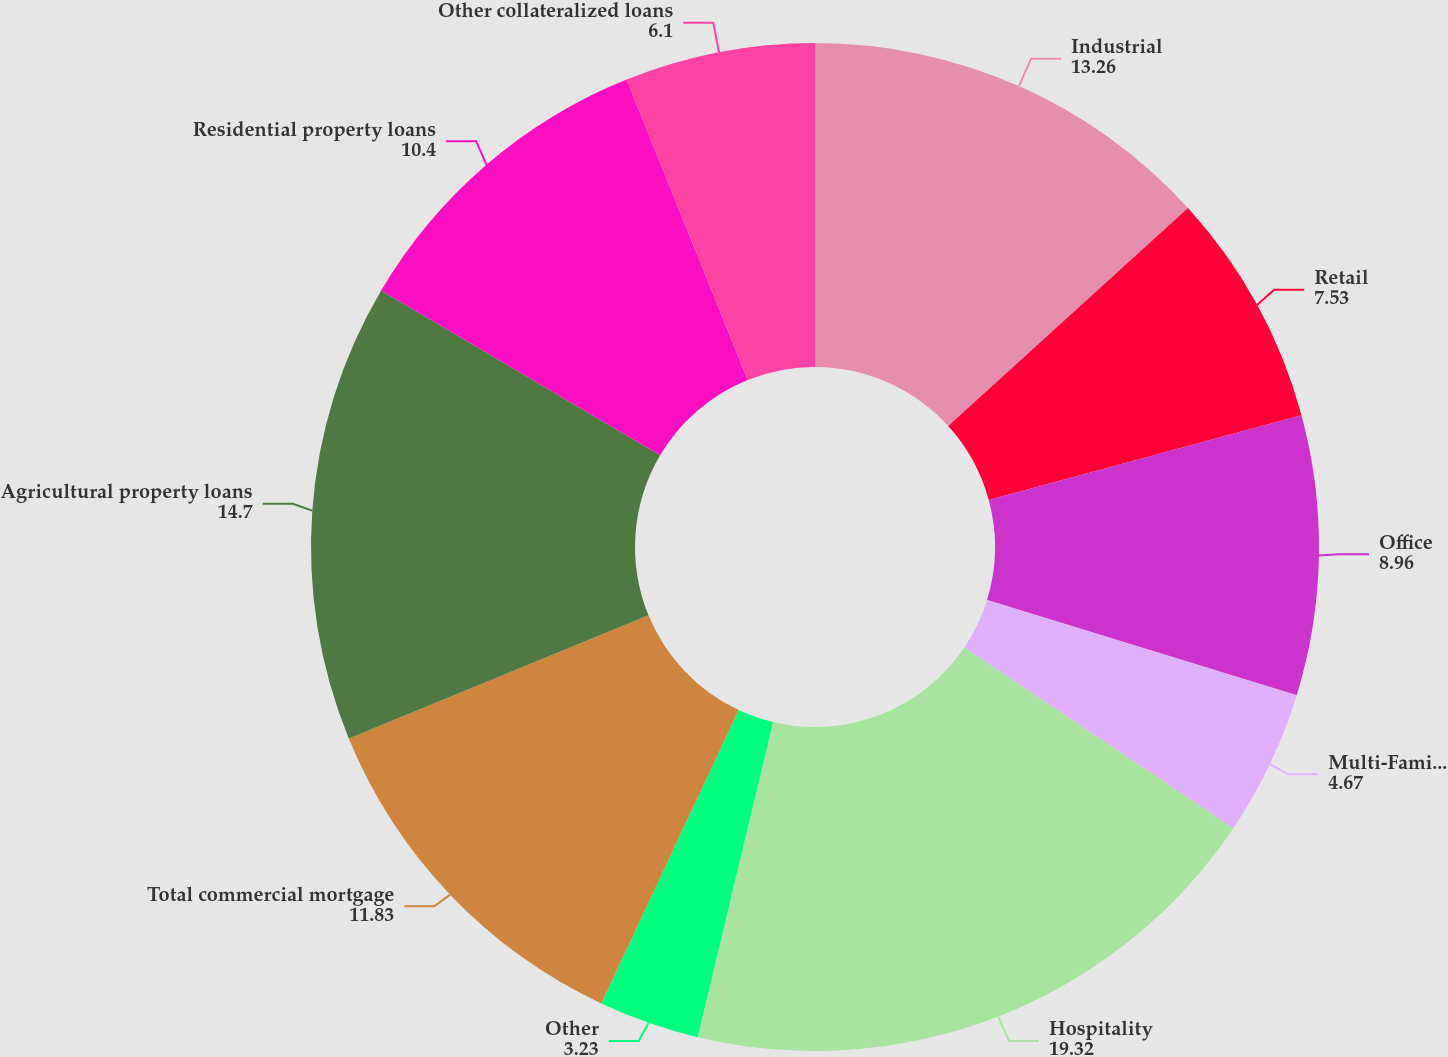Convert chart. <chart><loc_0><loc_0><loc_500><loc_500><pie_chart><fcel>Industrial<fcel>Retail<fcel>Office<fcel>Multi-Family/Apartment<fcel>Hospitality<fcel>Other<fcel>Total commercial mortgage<fcel>Agricultural property loans<fcel>Residential property loans<fcel>Other collateralized loans<nl><fcel>13.26%<fcel>7.53%<fcel>8.96%<fcel>4.67%<fcel>19.32%<fcel>3.23%<fcel>11.83%<fcel>14.7%<fcel>10.4%<fcel>6.1%<nl></chart> 